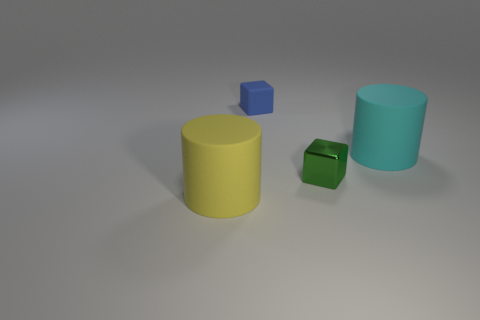Add 2 large blue rubber cylinders. How many objects exist? 6 Subtract all small metal blocks. Subtract all large red cylinders. How many objects are left? 3 Add 2 big things. How many big things are left? 4 Add 3 blue rubber cubes. How many blue rubber cubes exist? 4 Subtract 0 red blocks. How many objects are left? 4 